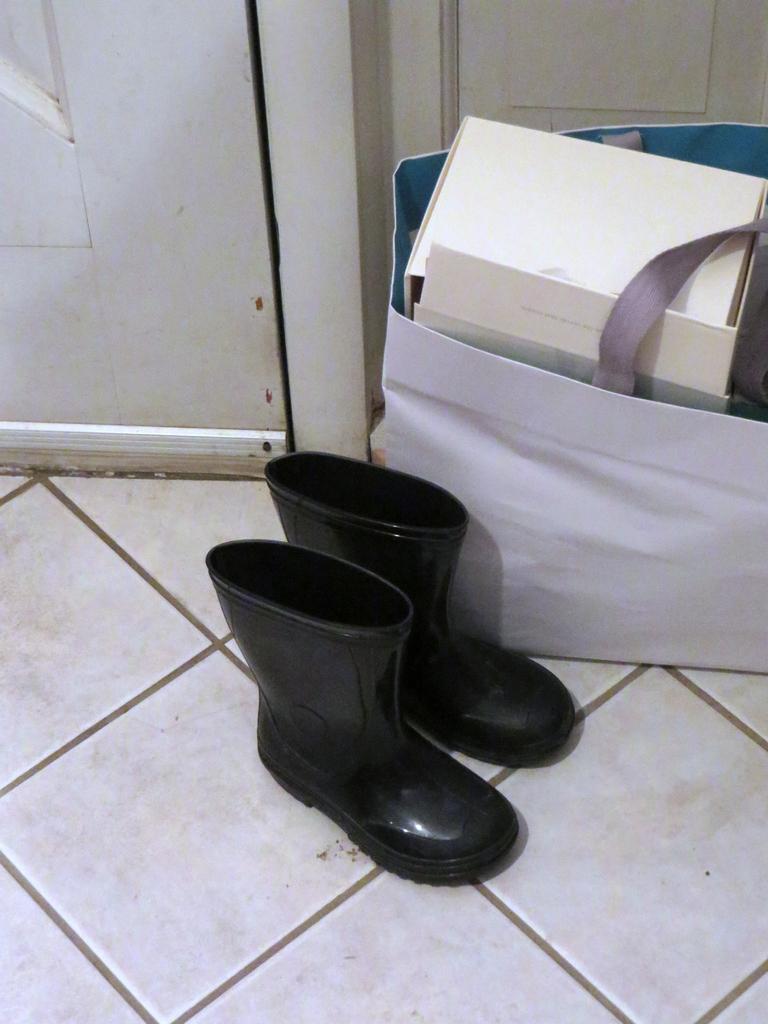Please provide a concise description of this image. In this image I can see two black colour shoes, a white colour bag and in it I can see few white colour boxes. On the top left side of this image I can see a door. 